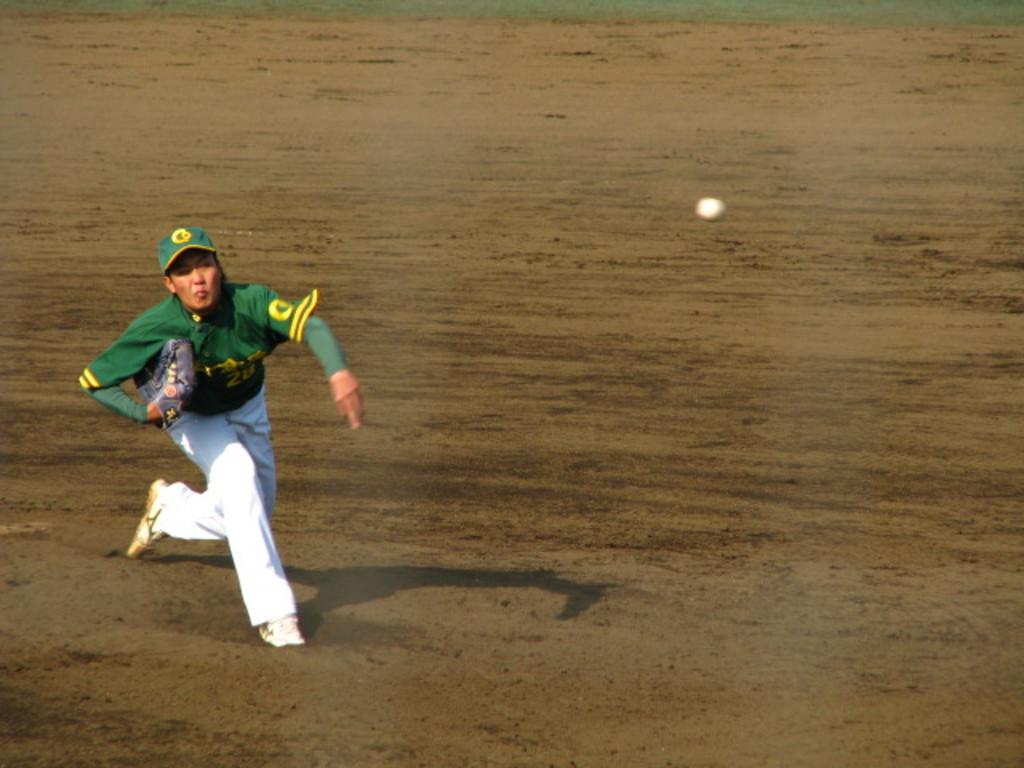What is the main subject of the image? There is a person in the image. What is the person wearing on their hands? The person is wearing gloves. What activity is the person engaged in? The person is running on the ground. What object is visible in the image? There is a ball visible in the image. What type of marble is being used to play a game in the image? There is no marble present in the image; it features a person running with a ball. What ingredients are used to make the stew in the image? There is no stew present in the image; it features a person running with a ball. 